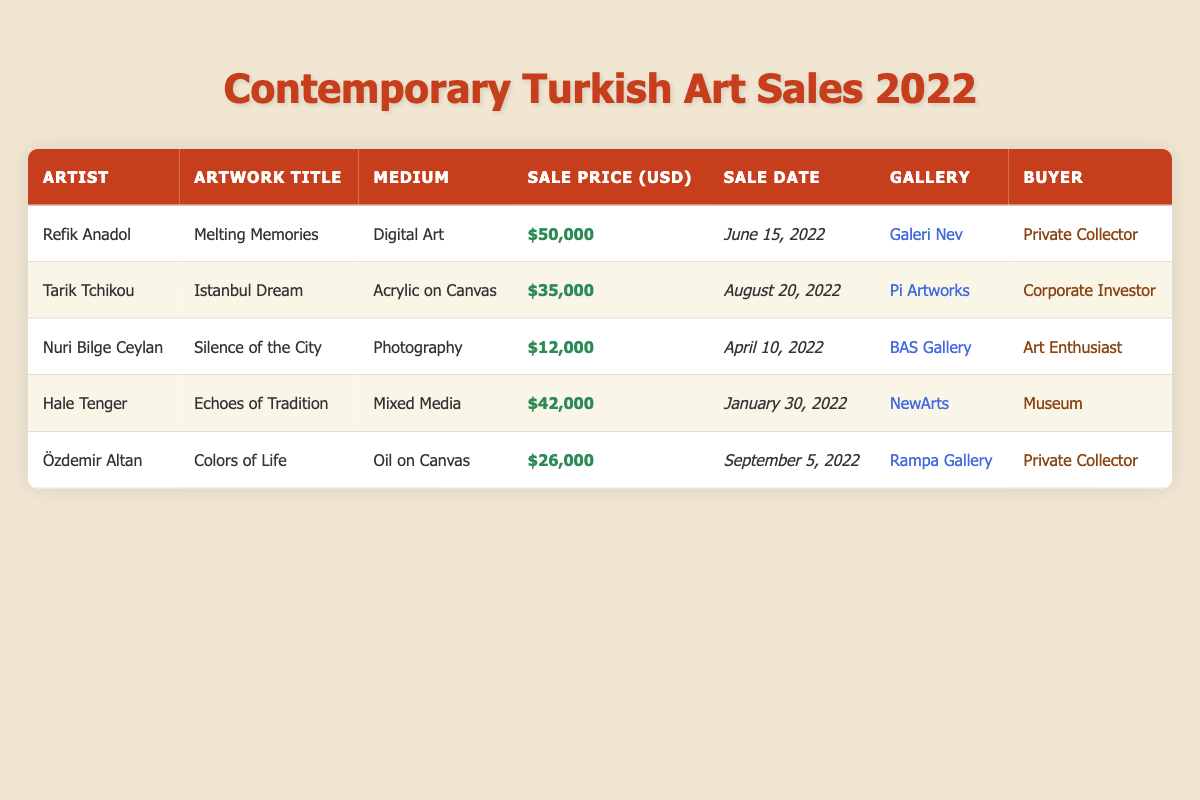What is the highest sale price among the artworks listed? The highest sale price can be retrieved by comparing the sale prices in the table. The artworks with their respective prices are: Refik Anadol - $50,000, Tarik Tchikou - $35,000, Nuri Bilge Ceylan - $12,000, Hale Tenger - $42,000, and Özdemir Altan - $26,000. The highest value is $50,000 for Refik Anadol's artwork.
Answer: $50,000 Which artist sold a piece of artwork for the lowest price? To find the lowest sale price, we look at the sale prices of all the artists. The prices are $50,000, $35,000, $12,000, $42,000, and $26,000. Nuri Bilge Ceylan sold his artwork for $12,000, which is the lowest price in the list.
Answer: Nuri Bilge Ceylan How many artworks were sold by private collectors? We can identify the buyers who are private collectors from the table. Refik Anadol and Özdemir Altan both sold their artworks to private collectors, making it a total of 2 artworks sold by private collectors.
Answer: 2 What is the total sale amount from all artworks? To find the total sale amount, we sum the prices of all the artworks: $50,000 + $35,000 + $12,000 + $42,000 + $26,000. This gives us a total sale amount of $165,000 for all artworks combined.
Answer: $165,000 Did any artwork sell for more than $30,000, and if so, how many? We check the sale prices in the table. The prices greater than $30,000 are $50,000 (Refik Anadol), $35,000 (Tarik Tchikou), and $42,000 (Hale Tenger), totaling 3 artworks sold for more than $30,000.
Answer: Yes, 3 artworks What is the average sale price of the artworks sold? To find the average sale price, we first sum the sale prices, which equals $165,000 as calculated earlier. Since there are 5 artworks, we divide the total by 5, resulting in an average sale price of $33,000.
Answer: $33,000 Which buyer purchased Hale Tenger's artwork? Looking at the entry for Hale Tenger, we see the buyer is listed as "Museum" next to the artwork "Echoes of Tradition." Thus, the buyer of Hale Tenger’s artwork is the Museum.
Answer: Museum What type of medium was used by Tarik Tchikou? From the table, we see that Tarik Tchikou's artwork "Istanbul Dream" is categorized under the medium "Acrylic on Canvas."
Answer: Acrylic on Canvas Which gallery sold the most expensive artwork? The most expensive artwork is by Refik Anadol, sold for $50,000, and it was sold at "Galeri Nev." Therefore, Galeri Nev is the gallery that sold the most expensive artwork.
Answer: Galeri Nev 